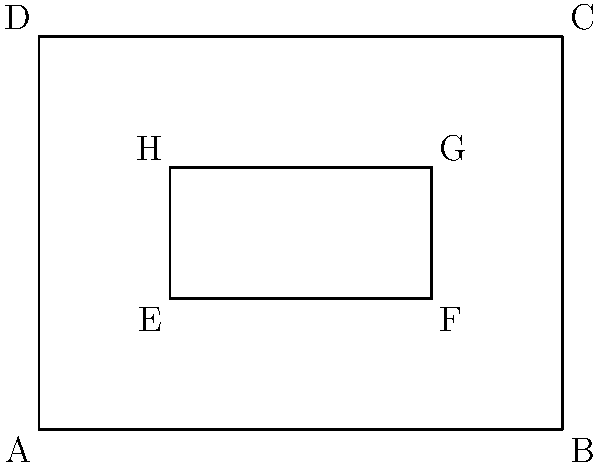As a frugal fashionista designing affordable wedding dresses, you're analyzing a dress pattern with two rectangles: ABCD (outer) and EFGH (inner). If AB = 4 units, BC = 3 units, EF = 2 units, and FG = 1 unit, which pair of triangles formed by the rectangles' diagonals are congruent? To determine which pair of triangles are congruent, we need to follow these steps:

1. Identify the triangles formed by the diagonals of both rectangles.
2. Compare the properties of these triangles.

Step 1: Identifying the triangles
- In rectangle ABCD, the diagonals form triangles ABC and ACD.
- In rectangle EFGH, the diagonals form triangles EFG and EGH.

Step 2: Comparing the properties
For rectangles, we know that:
- Diagonals bisect each other
- Diagonals are equal in length

For rectangle ABCD:
- AB = 4 units, BC = 3 units
- Area = 4 * 3 = 12 square units
- Diagonal length = $\sqrt{4^2 + 3^2} = 5$ units

For rectangle EFGH:
- EF = 2 units, FG = 1 unit
- Area = 2 * 1 = 2 square units
- Diagonal length = $\sqrt{2^2 + 1^2} = \sqrt{5}$ units

Triangles ABC and ACD:
- They share the same hypotenuse (diagonal of ABCD)
- They have equal areas (half of rectangle ABCD's area)
- They have the same side lengths (AB = 4, BC = 3, AC = 5)

Triangles EFG and EGH:
- They share the same hypotenuse (diagonal of EFGH)
- They have equal areas (half of rectangle EFGH's area)
- They have the same side lengths (EF = 2, FG = 1, EG = $\sqrt{5}$)

Conclusion: Triangles ABC and ACD are congruent to each other, and triangles EFG and EGH are congruent to each other. However, the triangles from the outer rectangle are not congruent to the triangles from the inner rectangle due to different side lengths and areas.
Answer: ABC and ACD 